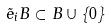<formula> <loc_0><loc_0><loc_500><loc_500>\tilde { e } _ { i } B \subset B \cup \{ 0 \}</formula> 